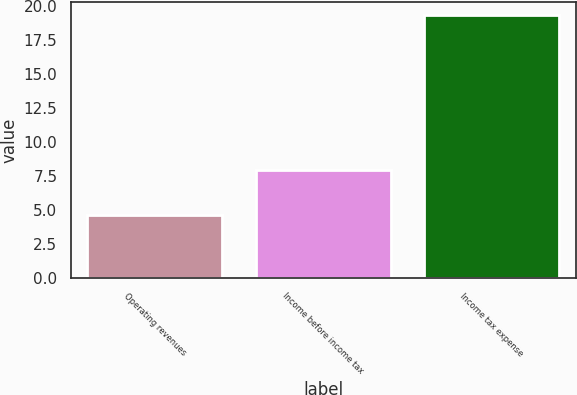Convert chart to OTSL. <chart><loc_0><loc_0><loc_500><loc_500><bar_chart><fcel>Operating revenues<fcel>Income before income tax<fcel>Income tax expense<nl><fcel>4.6<fcel>7.9<fcel>19.3<nl></chart> 